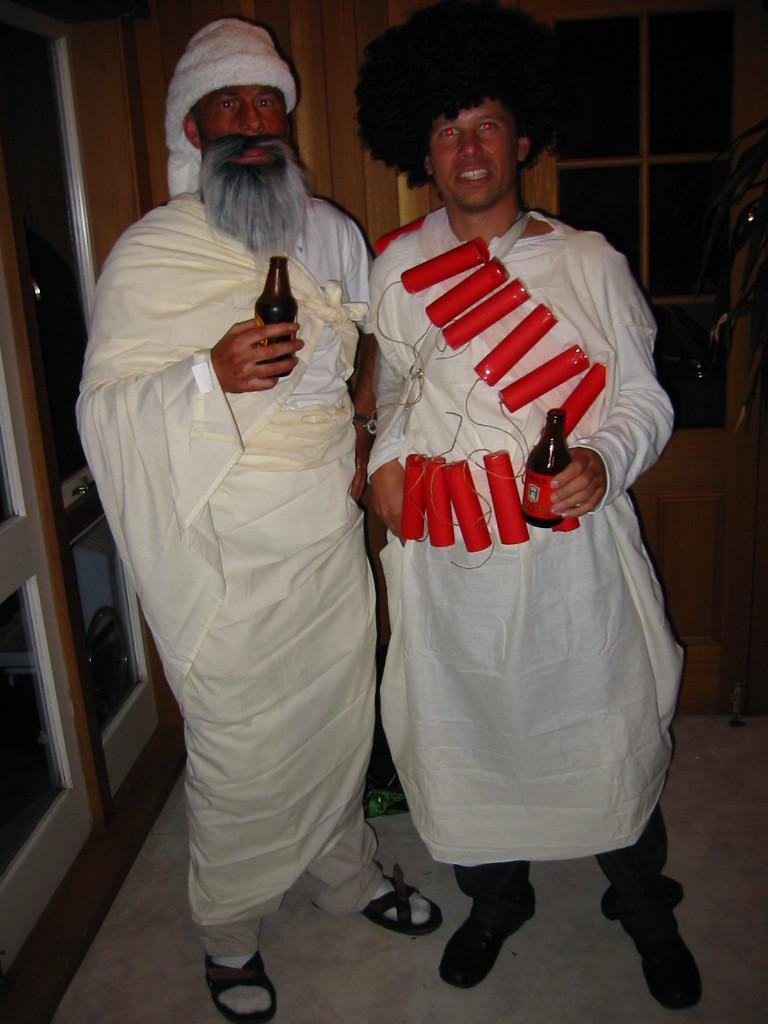How many people are in the image? There are two people in the image. What are the two people doing in the image? The two people are standing together. What are the people holding in their hands? Both people are holding bottles in their hands. Can you describe what one of the people is wearing? One of the people is wearing something on their body. What type of star can be seen in the image? There is no star present in the image. What appliance is being used by the people in the image? There is no appliance visible in the image; the people are holding bottles. 